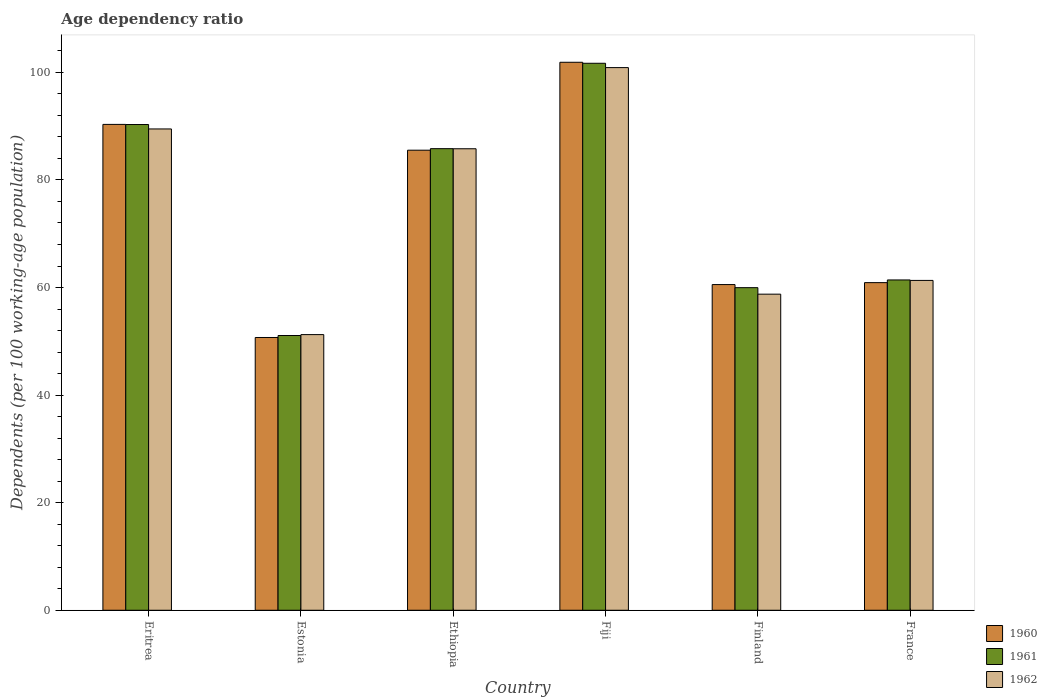How many groups of bars are there?
Give a very brief answer. 6. Are the number of bars on each tick of the X-axis equal?
Your response must be concise. Yes. How many bars are there on the 3rd tick from the left?
Your answer should be very brief. 3. How many bars are there on the 1st tick from the right?
Offer a terse response. 3. In how many cases, is the number of bars for a given country not equal to the number of legend labels?
Your response must be concise. 0. What is the age dependency ratio in in 1962 in Estonia?
Offer a very short reply. 51.25. Across all countries, what is the maximum age dependency ratio in in 1961?
Offer a terse response. 101.69. Across all countries, what is the minimum age dependency ratio in in 1960?
Give a very brief answer. 50.71. In which country was the age dependency ratio in in 1962 maximum?
Offer a terse response. Fiji. In which country was the age dependency ratio in in 1961 minimum?
Offer a terse response. Estonia. What is the total age dependency ratio in in 1960 in the graph?
Offer a terse response. 449.9. What is the difference between the age dependency ratio in in 1962 in Fiji and that in France?
Ensure brevity in your answer.  39.56. What is the difference between the age dependency ratio in in 1960 in Ethiopia and the age dependency ratio in in 1961 in Finland?
Provide a short and direct response. 25.55. What is the average age dependency ratio in in 1961 per country?
Provide a short and direct response. 75.04. What is the difference between the age dependency ratio in of/in 1960 and age dependency ratio in of/in 1962 in France?
Your answer should be very brief. -0.41. What is the ratio of the age dependency ratio in in 1962 in Eritrea to that in France?
Offer a terse response. 1.46. What is the difference between the highest and the second highest age dependency ratio in in 1961?
Your response must be concise. 4.49. What is the difference between the highest and the lowest age dependency ratio in in 1960?
Offer a very short reply. 51.17. Is the sum of the age dependency ratio in in 1961 in Eritrea and France greater than the maximum age dependency ratio in in 1960 across all countries?
Make the answer very short. Yes. What does the 3rd bar from the left in Fiji represents?
Provide a succinct answer. 1962. What does the 2nd bar from the right in Ethiopia represents?
Your answer should be very brief. 1961. Is it the case that in every country, the sum of the age dependency ratio in in 1960 and age dependency ratio in in 1962 is greater than the age dependency ratio in in 1961?
Offer a very short reply. Yes. Are all the bars in the graph horizontal?
Give a very brief answer. No. Does the graph contain any zero values?
Offer a terse response. No. Does the graph contain grids?
Offer a very short reply. No. How many legend labels are there?
Provide a succinct answer. 3. What is the title of the graph?
Keep it short and to the point. Age dependency ratio. Does "2006" appear as one of the legend labels in the graph?
Your response must be concise. No. What is the label or title of the Y-axis?
Your answer should be very brief. Dependents (per 100 working-age population). What is the Dependents (per 100 working-age population) of 1960 in Eritrea?
Make the answer very short. 90.33. What is the Dependents (per 100 working-age population) of 1961 in Eritrea?
Offer a terse response. 90.3. What is the Dependents (per 100 working-age population) in 1962 in Eritrea?
Give a very brief answer. 89.48. What is the Dependents (per 100 working-age population) in 1960 in Estonia?
Provide a succinct answer. 50.71. What is the Dependents (per 100 working-age population) in 1961 in Estonia?
Keep it short and to the point. 51.08. What is the Dependents (per 100 working-age population) in 1962 in Estonia?
Your answer should be compact. 51.25. What is the Dependents (per 100 working-age population) of 1960 in Ethiopia?
Offer a very short reply. 85.53. What is the Dependents (per 100 working-age population) of 1961 in Ethiopia?
Your answer should be compact. 85.82. What is the Dependents (per 100 working-age population) of 1962 in Ethiopia?
Your response must be concise. 85.8. What is the Dependents (per 100 working-age population) in 1960 in Fiji?
Offer a terse response. 101.87. What is the Dependents (per 100 working-age population) of 1961 in Fiji?
Ensure brevity in your answer.  101.69. What is the Dependents (per 100 working-age population) in 1962 in Fiji?
Ensure brevity in your answer.  100.89. What is the Dependents (per 100 working-age population) in 1960 in Finland?
Offer a very short reply. 60.55. What is the Dependents (per 100 working-age population) of 1961 in Finland?
Provide a succinct answer. 59.97. What is the Dependents (per 100 working-age population) of 1962 in Finland?
Offer a very short reply. 58.76. What is the Dependents (per 100 working-age population) of 1960 in France?
Offer a very short reply. 60.91. What is the Dependents (per 100 working-age population) of 1961 in France?
Give a very brief answer. 61.41. What is the Dependents (per 100 working-age population) in 1962 in France?
Your response must be concise. 61.32. Across all countries, what is the maximum Dependents (per 100 working-age population) in 1960?
Provide a succinct answer. 101.87. Across all countries, what is the maximum Dependents (per 100 working-age population) of 1961?
Provide a short and direct response. 101.69. Across all countries, what is the maximum Dependents (per 100 working-age population) in 1962?
Offer a terse response. 100.89. Across all countries, what is the minimum Dependents (per 100 working-age population) of 1960?
Your answer should be very brief. 50.71. Across all countries, what is the minimum Dependents (per 100 working-age population) of 1961?
Provide a short and direct response. 51.08. Across all countries, what is the minimum Dependents (per 100 working-age population) in 1962?
Provide a succinct answer. 51.25. What is the total Dependents (per 100 working-age population) in 1960 in the graph?
Provide a short and direct response. 449.9. What is the total Dependents (per 100 working-age population) in 1961 in the graph?
Provide a succinct answer. 450.27. What is the total Dependents (per 100 working-age population) of 1962 in the graph?
Make the answer very short. 447.49. What is the difference between the Dependents (per 100 working-age population) of 1960 in Eritrea and that in Estonia?
Keep it short and to the point. 39.62. What is the difference between the Dependents (per 100 working-age population) of 1961 in Eritrea and that in Estonia?
Ensure brevity in your answer.  39.22. What is the difference between the Dependents (per 100 working-age population) of 1962 in Eritrea and that in Estonia?
Your response must be concise. 38.23. What is the difference between the Dependents (per 100 working-age population) of 1960 in Eritrea and that in Ethiopia?
Keep it short and to the point. 4.8. What is the difference between the Dependents (per 100 working-age population) of 1961 in Eritrea and that in Ethiopia?
Your response must be concise. 4.49. What is the difference between the Dependents (per 100 working-age population) in 1962 in Eritrea and that in Ethiopia?
Keep it short and to the point. 3.68. What is the difference between the Dependents (per 100 working-age population) in 1960 in Eritrea and that in Fiji?
Provide a succinct answer. -11.55. What is the difference between the Dependents (per 100 working-age population) of 1961 in Eritrea and that in Fiji?
Keep it short and to the point. -11.39. What is the difference between the Dependents (per 100 working-age population) in 1962 in Eritrea and that in Fiji?
Your response must be concise. -11.41. What is the difference between the Dependents (per 100 working-age population) in 1960 in Eritrea and that in Finland?
Offer a terse response. 29.78. What is the difference between the Dependents (per 100 working-age population) in 1961 in Eritrea and that in Finland?
Give a very brief answer. 30.33. What is the difference between the Dependents (per 100 working-age population) in 1962 in Eritrea and that in Finland?
Make the answer very short. 30.72. What is the difference between the Dependents (per 100 working-age population) in 1960 in Eritrea and that in France?
Offer a terse response. 29.42. What is the difference between the Dependents (per 100 working-age population) of 1961 in Eritrea and that in France?
Your answer should be very brief. 28.89. What is the difference between the Dependents (per 100 working-age population) in 1962 in Eritrea and that in France?
Your answer should be very brief. 28.16. What is the difference between the Dependents (per 100 working-age population) in 1960 in Estonia and that in Ethiopia?
Your answer should be very brief. -34.82. What is the difference between the Dependents (per 100 working-age population) in 1961 in Estonia and that in Ethiopia?
Offer a very short reply. -34.74. What is the difference between the Dependents (per 100 working-age population) of 1962 in Estonia and that in Ethiopia?
Provide a succinct answer. -34.55. What is the difference between the Dependents (per 100 working-age population) of 1960 in Estonia and that in Fiji?
Provide a short and direct response. -51.17. What is the difference between the Dependents (per 100 working-age population) in 1961 in Estonia and that in Fiji?
Ensure brevity in your answer.  -50.61. What is the difference between the Dependents (per 100 working-age population) in 1962 in Estonia and that in Fiji?
Your response must be concise. -49.64. What is the difference between the Dependents (per 100 working-age population) in 1960 in Estonia and that in Finland?
Your answer should be very brief. -9.84. What is the difference between the Dependents (per 100 working-age population) in 1961 in Estonia and that in Finland?
Offer a very short reply. -8.9. What is the difference between the Dependents (per 100 working-age population) of 1962 in Estonia and that in Finland?
Your answer should be very brief. -7.52. What is the difference between the Dependents (per 100 working-age population) in 1960 in Estonia and that in France?
Give a very brief answer. -10.2. What is the difference between the Dependents (per 100 working-age population) in 1961 in Estonia and that in France?
Your answer should be compact. -10.33. What is the difference between the Dependents (per 100 working-age population) of 1962 in Estonia and that in France?
Your response must be concise. -10.08. What is the difference between the Dependents (per 100 working-age population) of 1960 in Ethiopia and that in Fiji?
Make the answer very short. -16.35. What is the difference between the Dependents (per 100 working-age population) in 1961 in Ethiopia and that in Fiji?
Provide a succinct answer. -15.87. What is the difference between the Dependents (per 100 working-age population) of 1962 in Ethiopia and that in Fiji?
Provide a short and direct response. -15.09. What is the difference between the Dependents (per 100 working-age population) of 1960 in Ethiopia and that in Finland?
Offer a terse response. 24.98. What is the difference between the Dependents (per 100 working-age population) in 1961 in Ethiopia and that in Finland?
Give a very brief answer. 25.84. What is the difference between the Dependents (per 100 working-age population) in 1962 in Ethiopia and that in Finland?
Your answer should be very brief. 27.03. What is the difference between the Dependents (per 100 working-age population) in 1960 in Ethiopia and that in France?
Give a very brief answer. 24.62. What is the difference between the Dependents (per 100 working-age population) of 1961 in Ethiopia and that in France?
Your answer should be very brief. 24.41. What is the difference between the Dependents (per 100 working-age population) of 1962 in Ethiopia and that in France?
Your response must be concise. 24.48. What is the difference between the Dependents (per 100 working-age population) of 1960 in Fiji and that in Finland?
Ensure brevity in your answer.  41.33. What is the difference between the Dependents (per 100 working-age population) of 1961 in Fiji and that in Finland?
Your response must be concise. 41.72. What is the difference between the Dependents (per 100 working-age population) in 1962 in Fiji and that in Finland?
Your response must be concise. 42.12. What is the difference between the Dependents (per 100 working-age population) in 1960 in Fiji and that in France?
Give a very brief answer. 40.96. What is the difference between the Dependents (per 100 working-age population) in 1961 in Fiji and that in France?
Your answer should be very brief. 40.28. What is the difference between the Dependents (per 100 working-age population) in 1962 in Fiji and that in France?
Give a very brief answer. 39.56. What is the difference between the Dependents (per 100 working-age population) in 1960 in Finland and that in France?
Your answer should be very brief. -0.36. What is the difference between the Dependents (per 100 working-age population) of 1961 in Finland and that in France?
Offer a terse response. -1.43. What is the difference between the Dependents (per 100 working-age population) in 1962 in Finland and that in France?
Your answer should be compact. -2.56. What is the difference between the Dependents (per 100 working-age population) in 1960 in Eritrea and the Dependents (per 100 working-age population) in 1961 in Estonia?
Offer a very short reply. 39.25. What is the difference between the Dependents (per 100 working-age population) in 1960 in Eritrea and the Dependents (per 100 working-age population) in 1962 in Estonia?
Make the answer very short. 39.08. What is the difference between the Dependents (per 100 working-age population) in 1961 in Eritrea and the Dependents (per 100 working-age population) in 1962 in Estonia?
Ensure brevity in your answer.  39.06. What is the difference between the Dependents (per 100 working-age population) of 1960 in Eritrea and the Dependents (per 100 working-age population) of 1961 in Ethiopia?
Give a very brief answer. 4.51. What is the difference between the Dependents (per 100 working-age population) of 1960 in Eritrea and the Dependents (per 100 working-age population) of 1962 in Ethiopia?
Ensure brevity in your answer.  4.53. What is the difference between the Dependents (per 100 working-age population) of 1961 in Eritrea and the Dependents (per 100 working-age population) of 1962 in Ethiopia?
Offer a terse response. 4.5. What is the difference between the Dependents (per 100 working-age population) in 1960 in Eritrea and the Dependents (per 100 working-age population) in 1961 in Fiji?
Your response must be concise. -11.36. What is the difference between the Dependents (per 100 working-age population) in 1960 in Eritrea and the Dependents (per 100 working-age population) in 1962 in Fiji?
Your answer should be compact. -10.56. What is the difference between the Dependents (per 100 working-age population) of 1961 in Eritrea and the Dependents (per 100 working-age population) of 1962 in Fiji?
Keep it short and to the point. -10.58. What is the difference between the Dependents (per 100 working-age population) in 1960 in Eritrea and the Dependents (per 100 working-age population) in 1961 in Finland?
Give a very brief answer. 30.35. What is the difference between the Dependents (per 100 working-age population) of 1960 in Eritrea and the Dependents (per 100 working-age population) of 1962 in Finland?
Keep it short and to the point. 31.56. What is the difference between the Dependents (per 100 working-age population) of 1961 in Eritrea and the Dependents (per 100 working-age population) of 1962 in Finland?
Give a very brief answer. 31.54. What is the difference between the Dependents (per 100 working-age population) of 1960 in Eritrea and the Dependents (per 100 working-age population) of 1961 in France?
Provide a short and direct response. 28.92. What is the difference between the Dependents (per 100 working-age population) of 1960 in Eritrea and the Dependents (per 100 working-age population) of 1962 in France?
Ensure brevity in your answer.  29. What is the difference between the Dependents (per 100 working-age population) in 1961 in Eritrea and the Dependents (per 100 working-age population) in 1962 in France?
Your response must be concise. 28.98. What is the difference between the Dependents (per 100 working-age population) of 1960 in Estonia and the Dependents (per 100 working-age population) of 1961 in Ethiopia?
Ensure brevity in your answer.  -35.11. What is the difference between the Dependents (per 100 working-age population) of 1960 in Estonia and the Dependents (per 100 working-age population) of 1962 in Ethiopia?
Provide a succinct answer. -35.09. What is the difference between the Dependents (per 100 working-age population) of 1961 in Estonia and the Dependents (per 100 working-age population) of 1962 in Ethiopia?
Your answer should be compact. -34.72. What is the difference between the Dependents (per 100 working-age population) in 1960 in Estonia and the Dependents (per 100 working-age population) in 1961 in Fiji?
Give a very brief answer. -50.98. What is the difference between the Dependents (per 100 working-age population) in 1960 in Estonia and the Dependents (per 100 working-age population) in 1962 in Fiji?
Offer a very short reply. -50.18. What is the difference between the Dependents (per 100 working-age population) of 1961 in Estonia and the Dependents (per 100 working-age population) of 1962 in Fiji?
Keep it short and to the point. -49.81. What is the difference between the Dependents (per 100 working-age population) of 1960 in Estonia and the Dependents (per 100 working-age population) of 1961 in Finland?
Your response must be concise. -9.27. What is the difference between the Dependents (per 100 working-age population) of 1960 in Estonia and the Dependents (per 100 working-age population) of 1962 in Finland?
Ensure brevity in your answer.  -8.06. What is the difference between the Dependents (per 100 working-age population) of 1961 in Estonia and the Dependents (per 100 working-age population) of 1962 in Finland?
Offer a terse response. -7.69. What is the difference between the Dependents (per 100 working-age population) of 1960 in Estonia and the Dependents (per 100 working-age population) of 1961 in France?
Offer a terse response. -10.7. What is the difference between the Dependents (per 100 working-age population) in 1960 in Estonia and the Dependents (per 100 working-age population) in 1962 in France?
Provide a succinct answer. -10.61. What is the difference between the Dependents (per 100 working-age population) in 1961 in Estonia and the Dependents (per 100 working-age population) in 1962 in France?
Make the answer very short. -10.24. What is the difference between the Dependents (per 100 working-age population) of 1960 in Ethiopia and the Dependents (per 100 working-age population) of 1961 in Fiji?
Make the answer very short. -16.16. What is the difference between the Dependents (per 100 working-age population) of 1960 in Ethiopia and the Dependents (per 100 working-age population) of 1962 in Fiji?
Ensure brevity in your answer.  -15.36. What is the difference between the Dependents (per 100 working-age population) of 1961 in Ethiopia and the Dependents (per 100 working-age population) of 1962 in Fiji?
Give a very brief answer. -15.07. What is the difference between the Dependents (per 100 working-age population) in 1960 in Ethiopia and the Dependents (per 100 working-age population) in 1961 in Finland?
Offer a very short reply. 25.55. What is the difference between the Dependents (per 100 working-age population) of 1960 in Ethiopia and the Dependents (per 100 working-age population) of 1962 in Finland?
Provide a succinct answer. 26.76. What is the difference between the Dependents (per 100 working-age population) in 1961 in Ethiopia and the Dependents (per 100 working-age population) in 1962 in Finland?
Keep it short and to the point. 27.05. What is the difference between the Dependents (per 100 working-age population) in 1960 in Ethiopia and the Dependents (per 100 working-age population) in 1961 in France?
Offer a very short reply. 24.12. What is the difference between the Dependents (per 100 working-age population) in 1960 in Ethiopia and the Dependents (per 100 working-age population) in 1962 in France?
Your answer should be very brief. 24.21. What is the difference between the Dependents (per 100 working-age population) of 1961 in Ethiopia and the Dependents (per 100 working-age population) of 1962 in France?
Provide a succinct answer. 24.49. What is the difference between the Dependents (per 100 working-age population) in 1960 in Fiji and the Dependents (per 100 working-age population) in 1961 in Finland?
Make the answer very short. 41.9. What is the difference between the Dependents (per 100 working-age population) of 1960 in Fiji and the Dependents (per 100 working-age population) of 1962 in Finland?
Keep it short and to the point. 43.11. What is the difference between the Dependents (per 100 working-age population) in 1961 in Fiji and the Dependents (per 100 working-age population) in 1962 in Finland?
Offer a terse response. 42.93. What is the difference between the Dependents (per 100 working-age population) in 1960 in Fiji and the Dependents (per 100 working-age population) in 1961 in France?
Offer a terse response. 40.47. What is the difference between the Dependents (per 100 working-age population) of 1960 in Fiji and the Dependents (per 100 working-age population) of 1962 in France?
Give a very brief answer. 40.55. What is the difference between the Dependents (per 100 working-age population) of 1961 in Fiji and the Dependents (per 100 working-age population) of 1962 in France?
Make the answer very short. 40.37. What is the difference between the Dependents (per 100 working-age population) in 1960 in Finland and the Dependents (per 100 working-age population) in 1961 in France?
Provide a short and direct response. -0.86. What is the difference between the Dependents (per 100 working-age population) of 1960 in Finland and the Dependents (per 100 working-age population) of 1962 in France?
Make the answer very short. -0.77. What is the difference between the Dependents (per 100 working-age population) in 1961 in Finland and the Dependents (per 100 working-age population) in 1962 in France?
Your answer should be very brief. -1.35. What is the average Dependents (per 100 working-age population) of 1960 per country?
Provide a short and direct response. 74.98. What is the average Dependents (per 100 working-age population) in 1961 per country?
Offer a terse response. 75.04. What is the average Dependents (per 100 working-age population) of 1962 per country?
Your response must be concise. 74.58. What is the difference between the Dependents (per 100 working-age population) in 1960 and Dependents (per 100 working-age population) in 1961 in Eritrea?
Your response must be concise. 0.02. What is the difference between the Dependents (per 100 working-age population) of 1960 and Dependents (per 100 working-age population) of 1962 in Eritrea?
Give a very brief answer. 0.85. What is the difference between the Dependents (per 100 working-age population) of 1961 and Dependents (per 100 working-age population) of 1962 in Eritrea?
Keep it short and to the point. 0.82. What is the difference between the Dependents (per 100 working-age population) in 1960 and Dependents (per 100 working-age population) in 1961 in Estonia?
Your response must be concise. -0.37. What is the difference between the Dependents (per 100 working-age population) of 1960 and Dependents (per 100 working-age population) of 1962 in Estonia?
Provide a short and direct response. -0.54. What is the difference between the Dependents (per 100 working-age population) in 1961 and Dependents (per 100 working-age population) in 1962 in Estonia?
Your answer should be compact. -0.17. What is the difference between the Dependents (per 100 working-age population) of 1960 and Dependents (per 100 working-age population) of 1961 in Ethiopia?
Make the answer very short. -0.29. What is the difference between the Dependents (per 100 working-age population) of 1960 and Dependents (per 100 working-age population) of 1962 in Ethiopia?
Provide a short and direct response. -0.27. What is the difference between the Dependents (per 100 working-age population) of 1961 and Dependents (per 100 working-age population) of 1962 in Ethiopia?
Your answer should be very brief. 0.02. What is the difference between the Dependents (per 100 working-age population) in 1960 and Dependents (per 100 working-age population) in 1961 in Fiji?
Your response must be concise. 0.18. What is the difference between the Dependents (per 100 working-age population) in 1960 and Dependents (per 100 working-age population) in 1962 in Fiji?
Offer a very short reply. 0.99. What is the difference between the Dependents (per 100 working-age population) in 1961 and Dependents (per 100 working-age population) in 1962 in Fiji?
Your response must be concise. 0.8. What is the difference between the Dependents (per 100 working-age population) of 1960 and Dependents (per 100 working-age population) of 1961 in Finland?
Keep it short and to the point. 0.58. What is the difference between the Dependents (per 100 working-age population) of 1960 and Dependents (per 100 working-age population) of 1962 in Finland?
Your answer should be very brief. 1.79. What is the difference between the Dependents (per 100 working-age population) of 1961 and Dependents (per 100 working-age population) of 1962 in Finland?
Ensure brevity in your answer.  1.21. What is the difference between the Dependents (per 100 working-age population) of 1960 and Dependents (per 100 working-age population) of 1961 in France?
Give a very brief answer. -0.5. What is the difference between the Dependents (per 100 working-age population) of 1960 and Dependents (per 100 working-age population) of 1962 in France?
Offer a very short reply. -0.41. What is the difference between the Dependents (per 100 working-age population) in 1961 and Dependents (per 100 working-age population) in 1962 in France?
Offer a terse response. 0.08. What is the ratio of the Dependents (per 100 working-age population) in 1960 in Eritrea to that in Estonia?
Keep it short and to the point. 1.78. What is the ratio of the Dependents (per 100 working-age population) of 1961 in Eritrea to that in Estonia?
Your response must be concise. 1.77. What is the ratio of the Dependents (per 100 working-age population) of 1962 in Eritrea to that in Estonia?
Make the answer very short. 1.75. What is the ratio of the Dependents (per 100 working-age population) of 1960 in Eritrea to that in Ethiopia?
Provide a succinct answer. 1.06. What is the ratio of the Dependents (per 100 working-age population) of 1961 in Eritrea to that in Ethiopia?
Your answer should be compact. 1.05. What is the ratio of the Dependents (per 100 working-age population) in 1962 in Eritrea to that in Ethiopia?
Provide a short and direct response. 1.04. What is the ratio of the Dependents (per 100 working-age population) in 1960 in Eritrea to that in Fiji?
Keep it short and to the point. 0.89. What is the ratio of the Dependents (per 100 working-age population) in 1961 in Eritrea to that in Fiji?
Your answer should be very brief. 0.89. What is the ratio of the Dependents (per 100 working-age population) in 1962 in Eritrea to that in Fiji?
Provide a short and direct response. 0.89. What is the ratio of the Dependents (per 100 working-age population) of 1960 in Eritrea to that in Finland?
Your answer should be compact. 1.49. What is the ratio of the Dependents (per 100 working-age population) of 1961 in Eritrea to that in Finland?
Provide a short and direct response. 1.51. What is the ratio of the Dependents (per 100 working-age population) of 1962 in Eritrea to that in Finland?
Offer a very short reply. 1.52. What is the ratio of the Dependents (per 100 working-age population) in 1960 in Eritrea to that in France?
Your answer should be very brief. 1.48. What is the ratio of the Dependents (per 100 working-age population) in 1961 in Eritrea to that in France?
Your answer should be very brief. 1.47. What is the ratio of the Dependents (per 100 working-age population) in 1962 in Eritrea to that in France?
Your answer should be very brief. 1.46. What is the ratio of the Dependents (per 100 working-age population) in 1960 in Estonia to that in Ethiopia?
Give a very brief answer. 0.59. What is the ratio of the Dependents (per 100 working-age population) in 1961 in Estonia to that in Ethiopia?
Give a very brief answer. 0.6. What is the ratio of the Dependents (per 100 working-age population) in 1962 in Estonia to that in Ethiopia?
Offer a very short reply. 0.6. What is the ratio of the Dependents (per 100 working-age population) of 1960 in Estonia to that in Fiji?
Your response must be concise. 0.5. What is the ratio of the Dependents (per 100 working-age population) of 1961 in Estonia to that in Fiji?
Provide a succinct answer. 0.5. What is the ratio of the Dependents (per 100 working-age population) in 1962 in Estonia to that in Fiji?
Provide a succinct answer. 0.51. What is the ratio of the Dependents (per 100 working-age population) of 1960 in Estonia to that in Finland?
Give a very brief answer. 0.84. What is the ratio of the Dependents (per 100 working-age population) of 1961 in Estonia to that in Finland?
Your answer should be very brief. 0.85. What is the ratio of the Dependents (per 100 working-age population) in 1962 in Estonia to that in Finland?
Your response must be concise. 0.87. What is the ratio of the Dependents (per 100 working-age population) in 1960 in Estonia to that in France?
Provide a succinct answer. 0.83. What is the ratio of the Dependents (per 100 working-age population) in 1961 in Estonia to that in France?
Make the answer very short. 0.83. What is the ratio of the Dependents (per 100 working-age population) in 1962 in Estonia to that in France?
Keep it short and to the point. 0.84. What is the ratio of the Dependents (per 100 working-age population) of 1960 in Ethiopia to that in Fiji?
Keep it short and to the point. 0.84. What is the ratio of the Dependents (per 100 working-age population) of 1961 in Ethiopia to that in Fiji?
Give a very brief answer. 0.84. What is the ratio of the Dependents (per 100 working-age population) of 1962 in Ethiopia to that in Fiji?
Your response must be concise. 0.85. What is the ratio of the Dependents (per 100 working-age population) of 1960 in Ethiopia to that in Finland?
Provide a succinct answer. 1.41. What is the ratio of the Dependents (per 100 working-age population) of 1961 in Ethiopia to that in Finland?
Keep it short and to the point. 1.43. What is the ratio of the Dependents (per 100 working-age population) in 1962 in Ethiopia to that in Finland?
Give a very brief answer. 1.46. What is the ratio of the Dependents (per 100 working-age population) of 1960 in Ethiopia to that in France?
Make the answer very short. 1.4. What is the ratio of the Dependents (per 100 working-age population) of 1961 in Ethiopia to that in France?
Provide a short and direct response. 1.4. What is the ratio of the Dependents (per 100 working-age population) in 1962 in Ethiopia to that in France?
Offer a very short reply. 1.4. What is the ratio of the Dependents (per 100 working-age population) of 1960 in Fiji to that in Finland?
Your answer should be compact. 1.68. What is the ratio of the Dependents (per 100 working-age population) in 1961 in Fiji to that in Finland?
Offer a terse response. 1.7. What is the ratio of the Dependents (per 100 working-age population) in 1962 in Fiji to that in Finland?
Provide a succinct answer. 1.72. What is the ratio of the Dependents (per 100 working-age population) of 1960 in Fiji to that in France?
Provide a succinct answer. 1.67. What is the ratio of the Dependents (per 100 working-age population) of 1961 in Fiji to that in France?
Your answer should be very brief. 1.66. What is the ratio of the Dependents (per 100 working-age population) of 1962 in Fiji to that in France?
Make the answer very short. 1.65. What is the ratio of the Dependents (per 100 working-age population) in 1960 in Finland to that in France?
Ensure brevity in your answer.  0.99. What is the ratio of the Dependents (per 100 working-age population) in 1961 in Finland to that in France?
Provide a short and direct response. 0.98. What is the difference between the highest and the second highest Dependents (per 100 working-age population) in 1960?
Provide a succinct answer. 11.55. What is the difference between the highest and the second highest Dependents (per 100 working-age population) in 1961?
Your answer should be compact. 11.39. What is the difference between the highest and the second highest Dependents (per 100 working-age population) of 1962?
Make the answer very short. 11.41. What is the difference between the highest and the lowest Dependents (per 100 working-age population) of 1960?
Offer a very short reply. 51.17. What is the difference between the highest and the lowest Dependents (per 100 working-age population) of 1961?
Your answer should be very brief. 50.61. What is the difference between the highest and the lowest Dependents (per 100 working-age population) of 1962?
Provide a short and direct response. 49.64. 